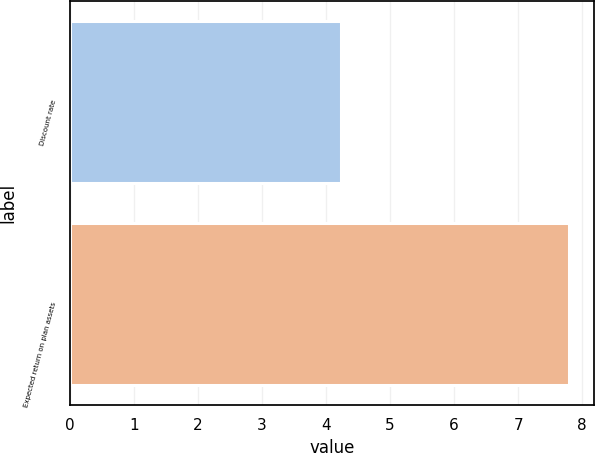<chart> <loc_0><loc_0><loc_500><loc_500><bar_chart><fcel>Discount rate<fcel>Expected return on plan assets<nl><fcel>4.23<fcel>7.8<nl></chart> 